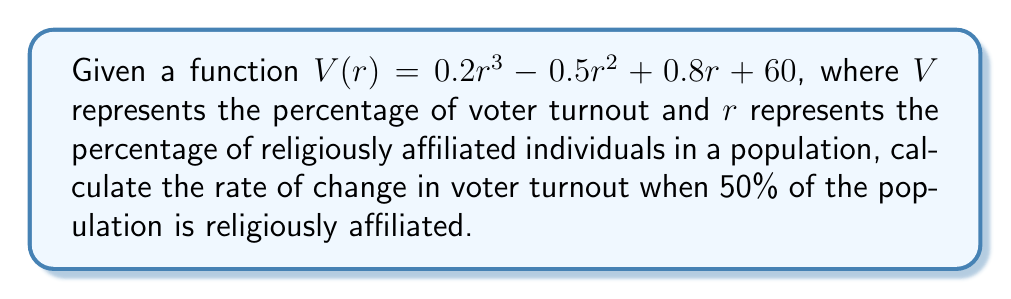Give your solution to this math problem. To find the rate of change in voter turnout, we need to calculate the derivative of the given function $V(r)$ and then evaluate it at $r = 50$.

Step 1: Calculate the derivative of $V(r)$
$$\frac{d}{dr}V(r) = \frac{d}{dr}(0.2r^3 - 0.5r^2 + 0.8r + 60)$$
$$V'(r) = 0.6r^2 - r + 0.8$$

Step 2: Evaluate the derivative at $r = 50$
$$V'(50) = 0.6(50)^2 - 50 + 0.8$$
$$V'(50) = 0.6(2500) - 50 + 0.8$$
$$V'(50) = 1500 - 50 + 0.8$$
$$V'(50) = 1450.8$$

The rate of change in voter turnout when 50% of the population is religiously affiliated is 1450.8 percentage points per unit change in religious affiliation percentage.
Answer: 1450.8 